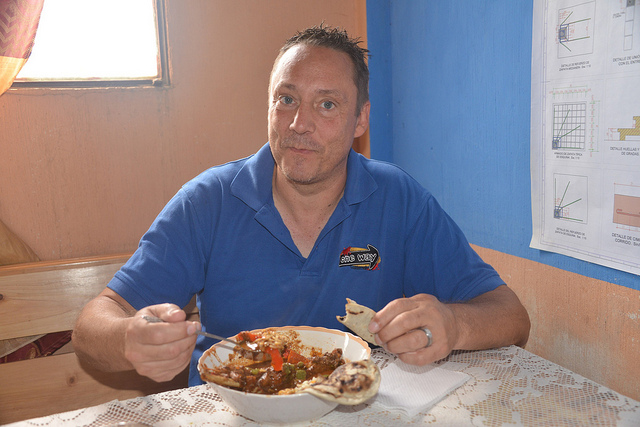<image>Where is the fork? The fork is not clearly visible in the image. However, it could be in the man's hand or in the bowl. Where is the fork? It is not clear where the fork is. It can be seen in the man's hand or it may not be pictured. 